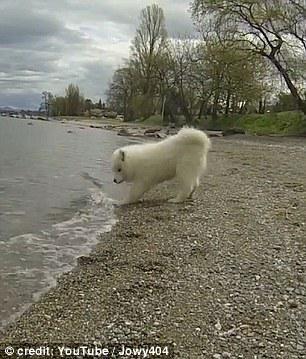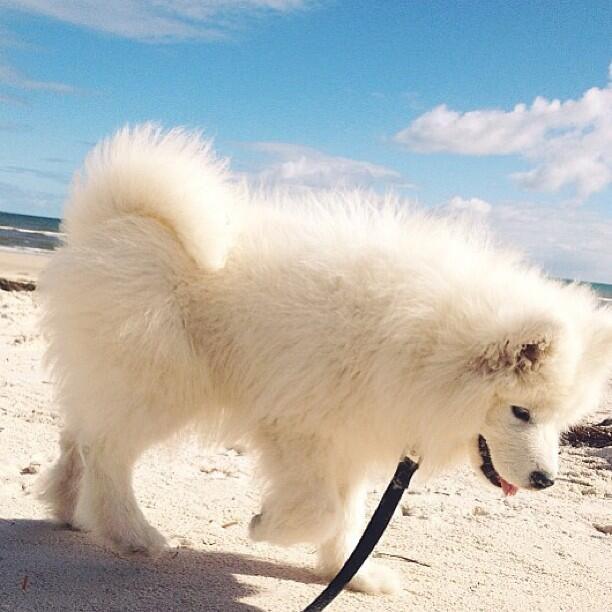The first image is the image on the left, the second image is the image on the right. Considering the images on both sides, is "The right image includes at least twice the number of dogs as the left image." valid? Answer yes or no. No. The first image is the image on the left, the second image is the image on the right. For the images shown, is this caption "A white dog is standing on the rocky shore of a beach." true? Answer yes or no. Yes. 